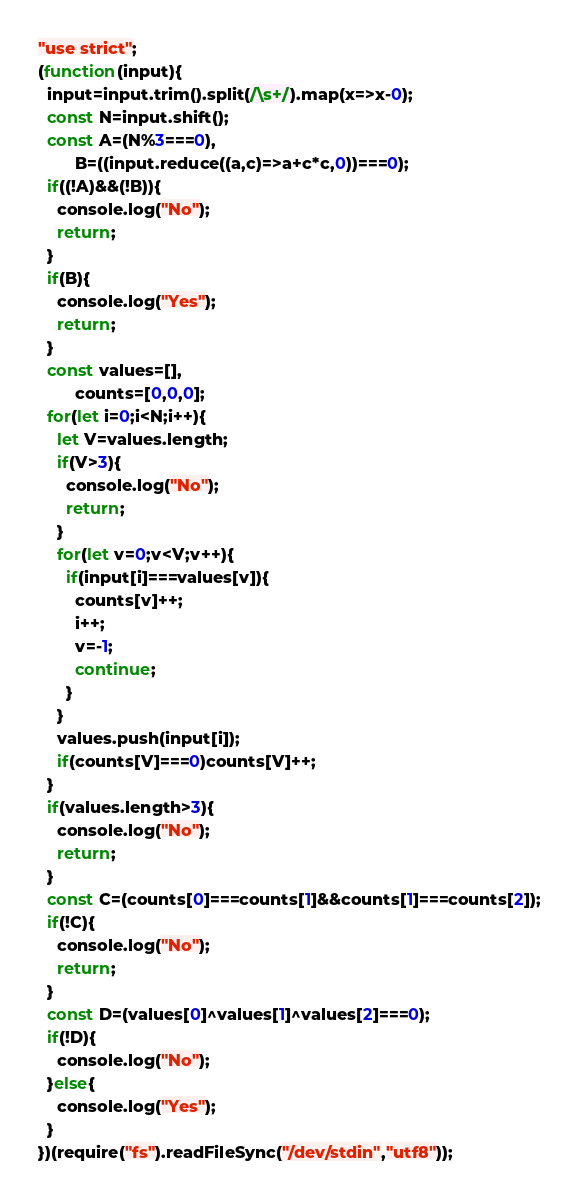Convert code to text. <code><loc_0><loc_0><loc_500><loc_500><_JavaScript_>"use strict";
(function(input){
  input=input.trim().split(/\s+/).map(x=>x-0);
  const N=input.shift();
  const A=(N%3===0),
        B=((input.reduce((a,c)=>a+c*c,0))===0);
  if((!A)&&(!B)){
    console.log("No");
    return;
  }
  if(B){
    console.log("Yes");
    return;
  }
  const values=[],
        counts=[0,0,0];
  for(let i=0;i<N;i++){
    let V=values.length;
    if(V>3){
      console.log("No");
      return;
    }
    for(let v=0;v<V;v++){
      if(input[i]===values[v]){
        counts[v]++;
        i++;
        v=-1;
        continue;
      }
    }
    values.push(input[i]);
    if(counts[V]===0)counts[V]++;
  }
  if(values.length>3){
    console.log("No");
    return;
  }
  const C=(counts[0]===counts[1]&&counts[1]===counts[2]);
  if(!C){
    console.log("No");
    return;
  }
  const D=(values[0]^values[1]^values[2]===0);
  if(!D){
    console.log("No");
  }else{
    console.log("Yes");
  }
})(require("fs").readFileSync("/dev/stdin","utf8"));
</code> 